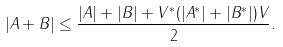<formula> <loc_0><loc_0><loc_500><loc_500>| A + B | \leq \frac { | A | + | B | + V ^ { * } ( | A ^ { * } | + | B ^ { * } | ) V } { 2 } .</formula> 